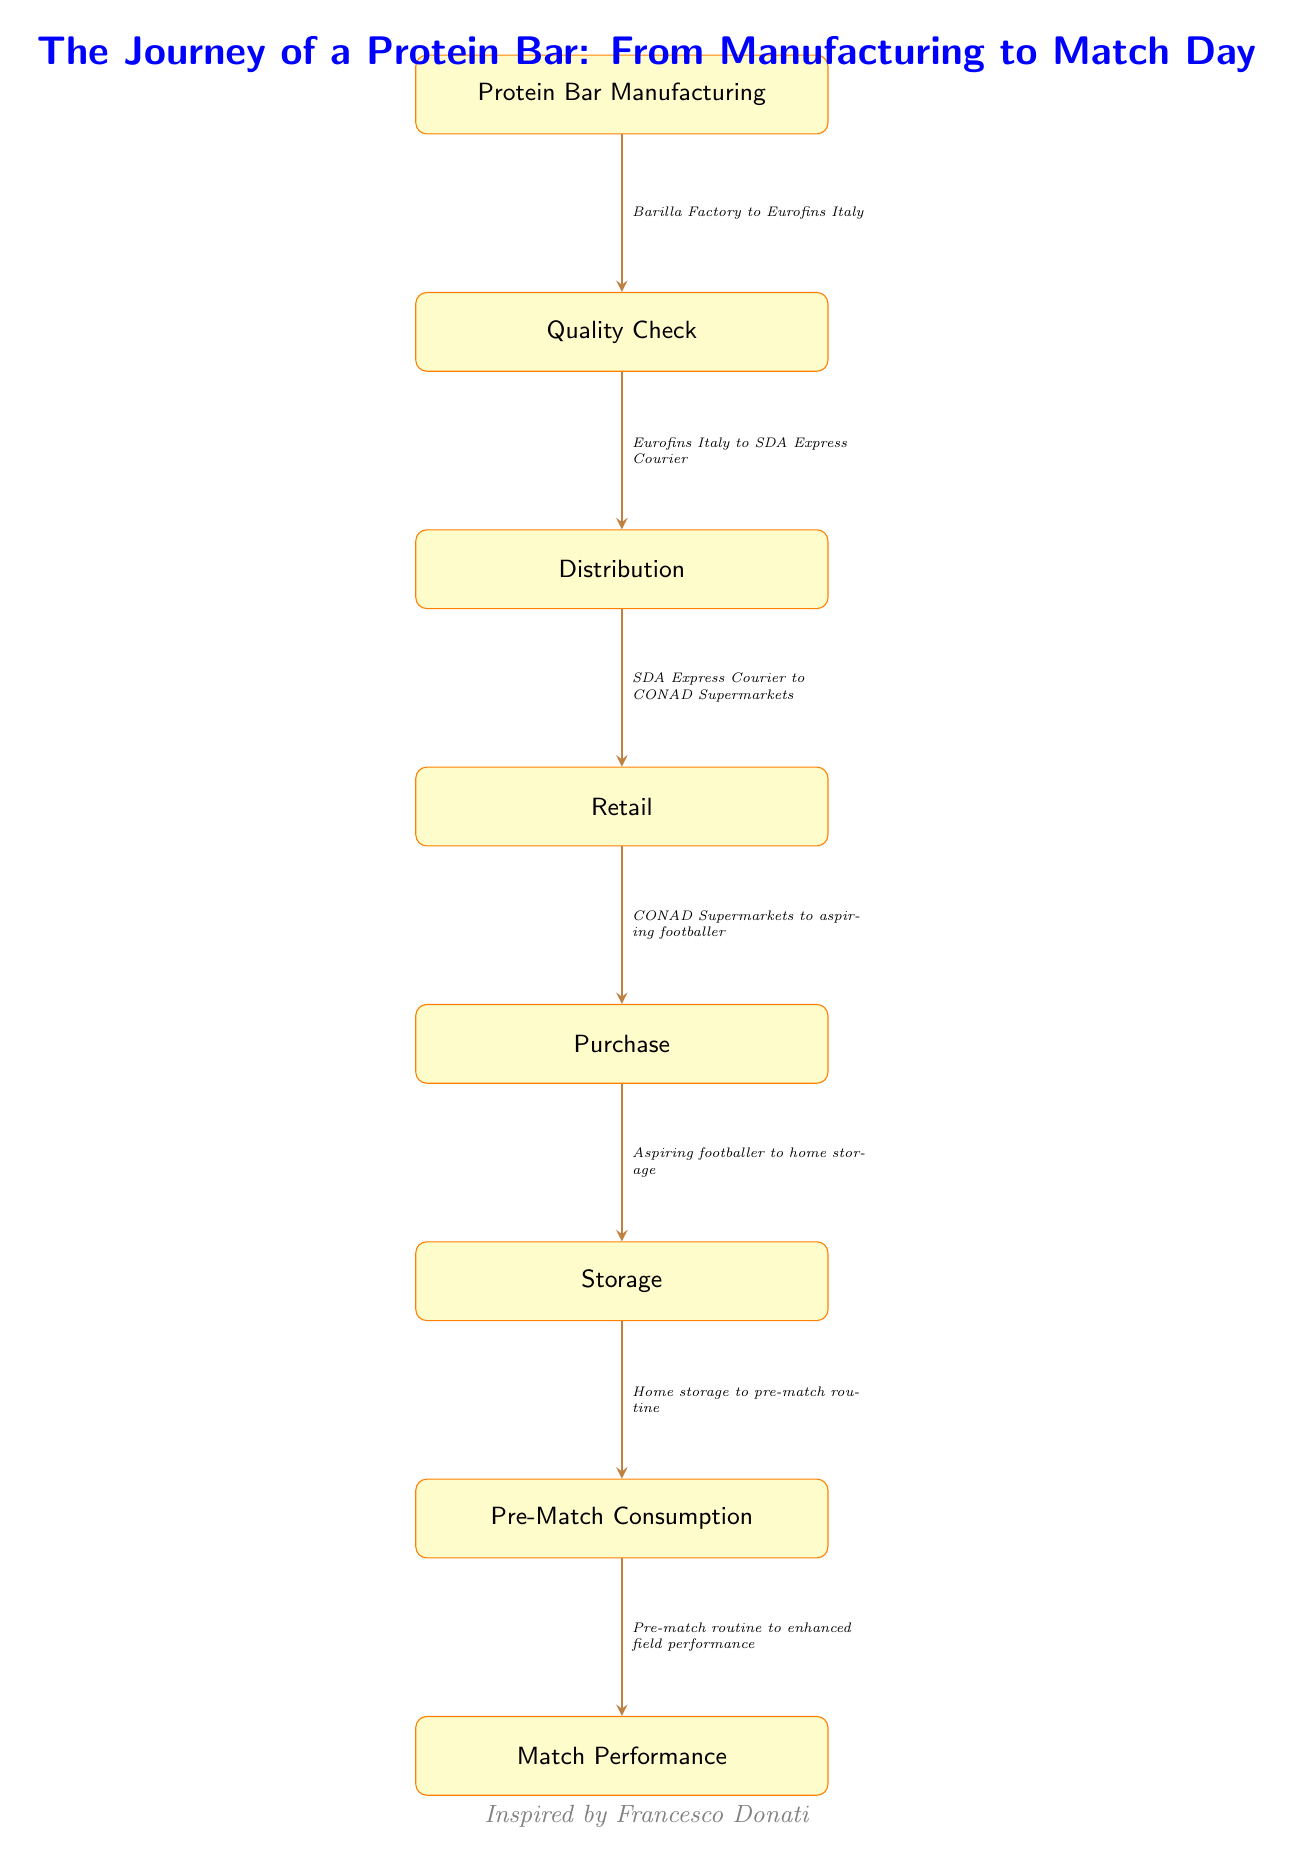What is the first step in the journey? The first step in the journey is "Protein Bar Manufacturing," which is the starting point of the flow in the diagram.
Answer: Protein Bar Manufacturing How many total steps are there in the journey? The diagram includes seven distinct steps or nodes in the journey, from manufacturing to match performance.
Answer: 7 What is the last step before consumption? The last step before consumption is "Storage," as it is the node immediately preceding "Pre-Match Consumption."
Answer: Storage Which node is directly after 'Quality Check'? The node directly after 'Quality Check' is 'Distribution', showing the sequential flow from one step to the next.
Answer: Distribution What type of transportation is mentioned in the journey? The diagram specifies "SDA Express Courier" as the means of transportation from the distribution node to the retail stage.
Answer: SDA Express Courier What is the relationship between purchase and storage? The relationship is that after the "Purchase" step, the protein bars are moved to "Storage", indicating that the bars are kept at home after being bought.
Answer: Aspiring footballer to home storage Which two nodes have the connection 'Home storage to pre-match routine'? The connection 'Home storage to pre-match routine' links the 'Storage' node to the 'Pre-Match Consumption' node, indicating flow from one direct action to the next.
Answer: Storage and Pre-Match Consumption What is the significance of the 'Pre-Match Consumption' step? The 'Pre-Match Consumption' step is crucial because it directly leads to 'Match Performance', showing that consuming the protein bar is intended to enhance performance during the match.
Answer: Enhanced field performance 